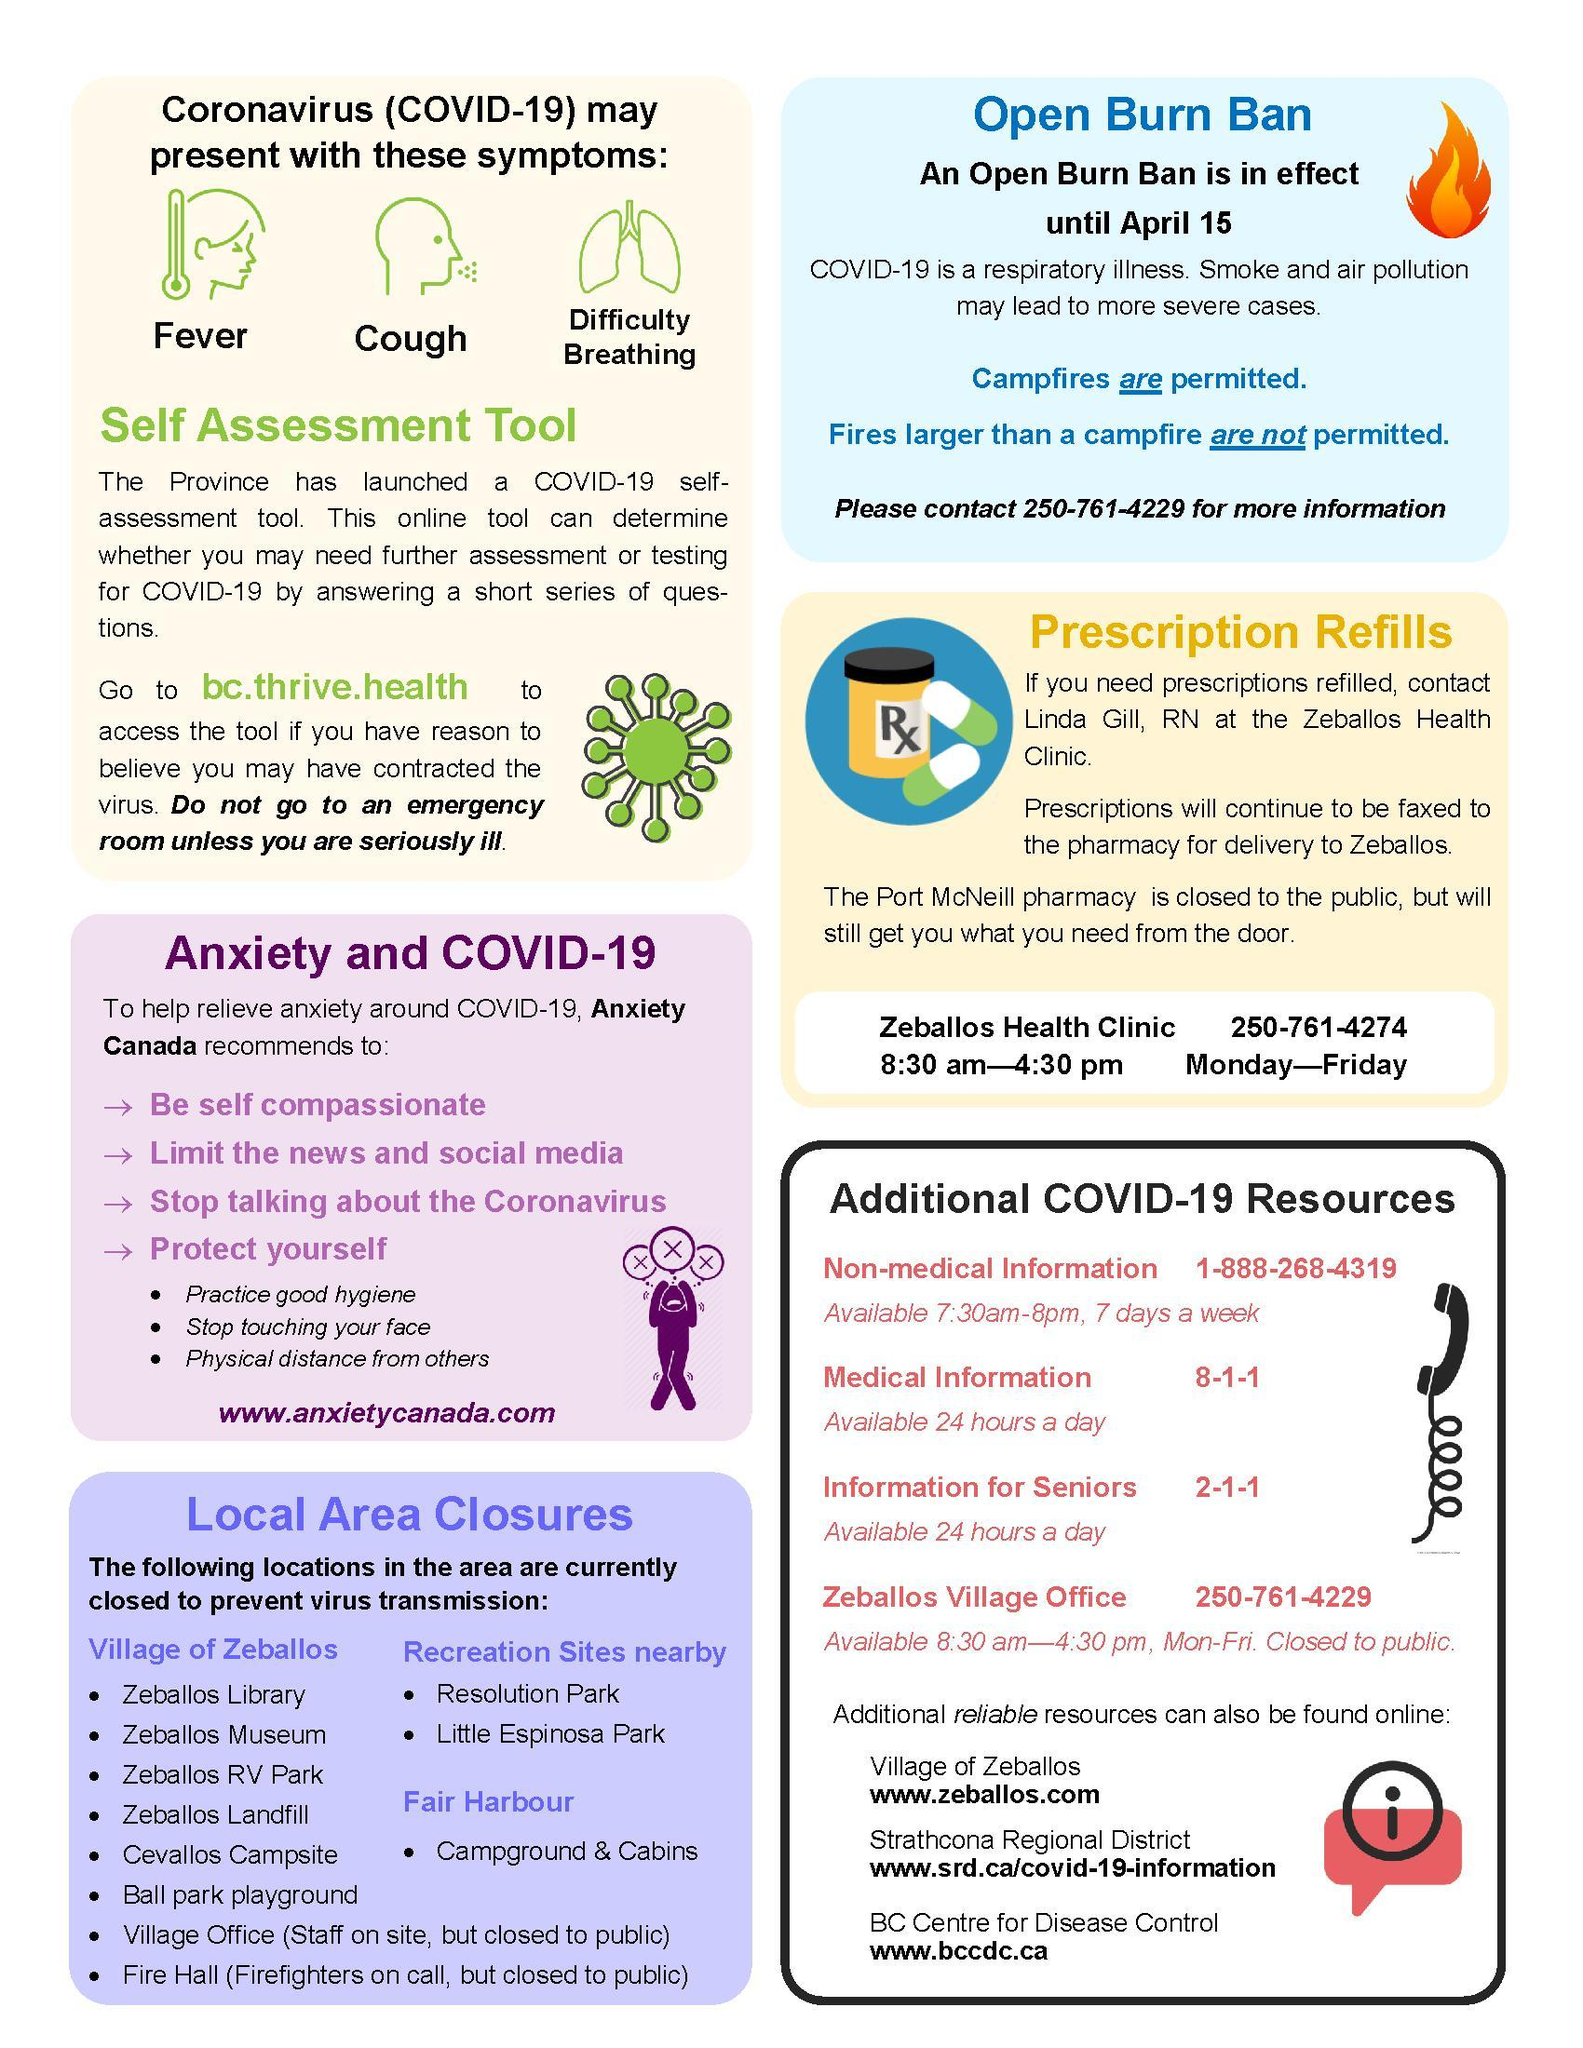What is the common symptom of coronavirus other than fever & cough?
Answer the question with a short phrase. Difficulty Breathing 